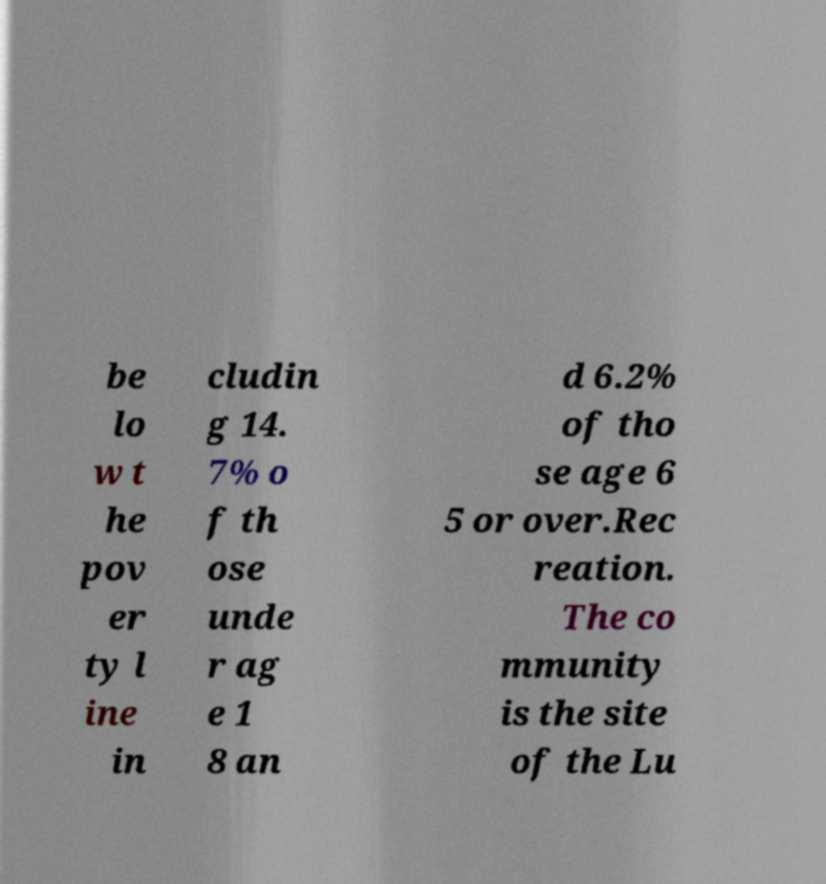There's text embedded in this image that I need extracted. Can you transcribe it verbatim? be lo w t he pov er ty l ine in cludin g 14. 7% o f th ose unde r ag e 1 8 an d 6.2% of tho se age 6 5 or over.Rec reation. The co mmunity is the site of the Lu 